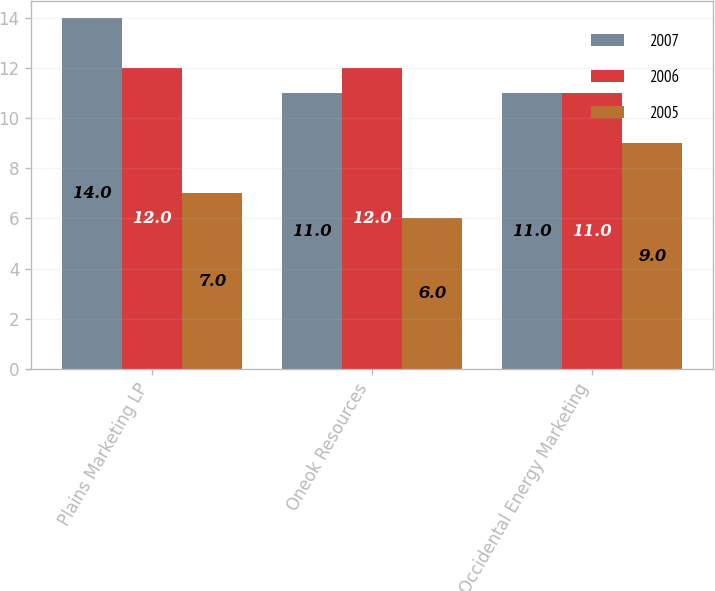Convert chart to OTSL. <chart><loc_0><loc_0><loc_500><loc_500><stacked_bar_chart><ecel><fcel>Plains Marketing LP<fcel>Oneok Resources<fcel>Occidental Energy Marketing<nl><fcel>2007<fcel>14<fcel>11<fcel>11<nl><fcel>2006<fcel>12<fcel>12<fcel>11<nl><fcel>2005<fcel>7<fcel>6<fcel>9<nl></chart> 